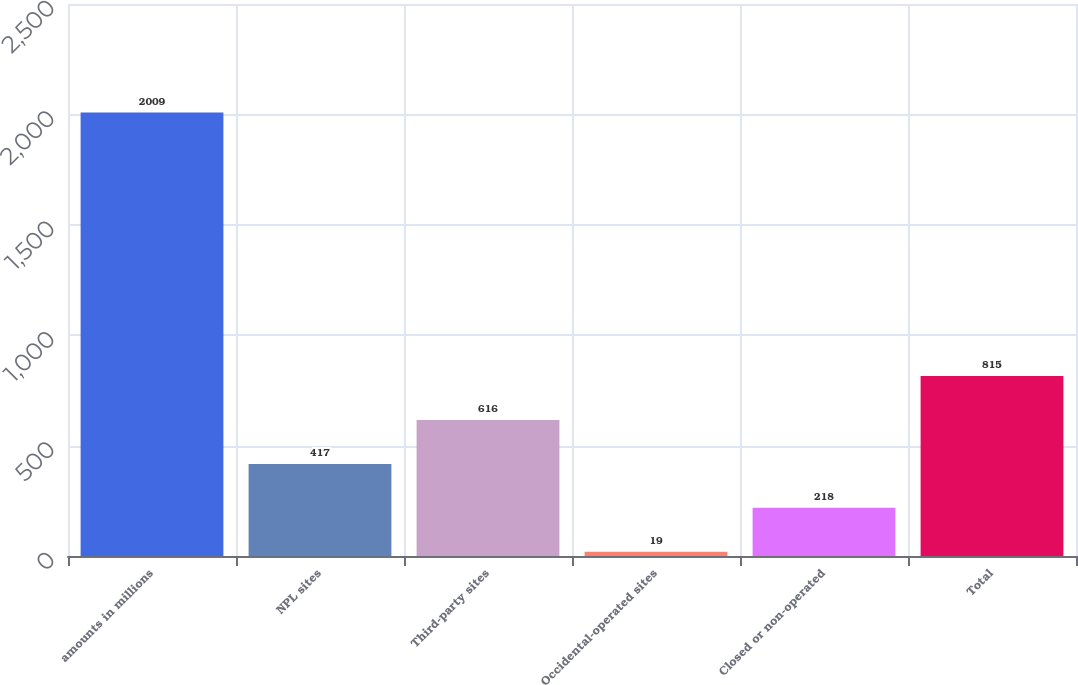Convert chart. <chart><loc_0><loc_0><loc_500><loc_500><bar_chart><fcel>amounts in millions<fcel>NPL sites<fcel>Third-party sites<fcel>Occidental-operated sites<fcel>Closed or non-operated<fcel>Total<nl><fcel>2009<fcel>417<fcel>616<fcel>19<fcel>218<fcel>815<nl></chart> 